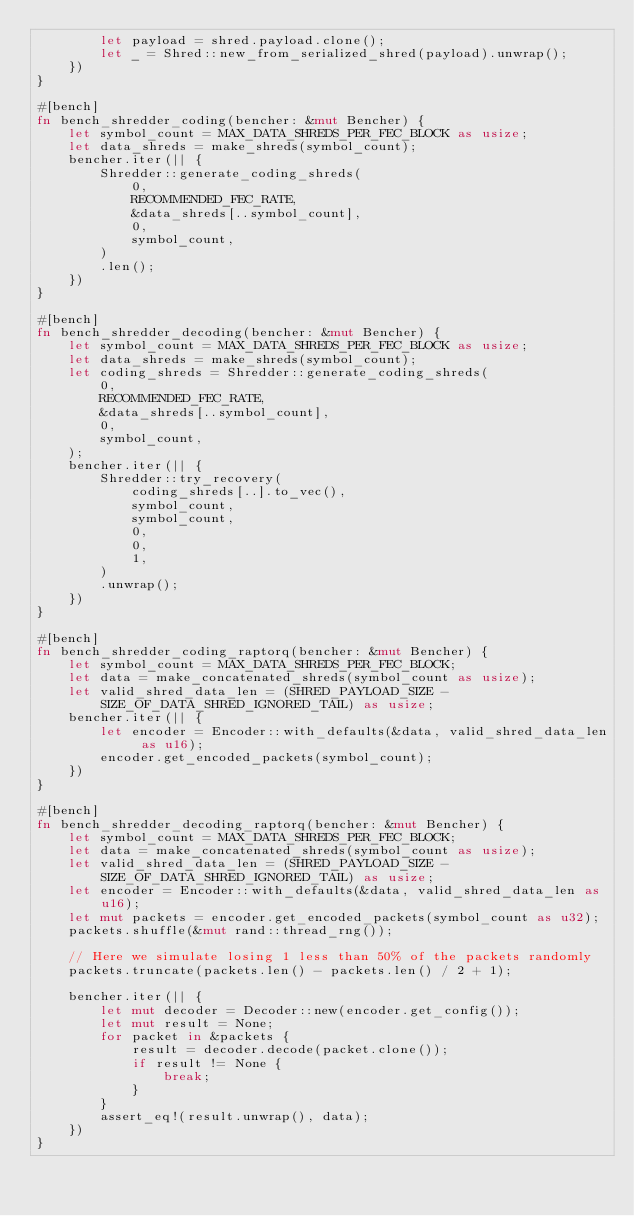Convert code to text. <code><loc_0><loc_0><loc_500><loc_500><_Rust_>        let payload = shred.payload.clone();
        let _ = Shred::new_from_serialized_shred(payload).unwrap();
    })
}

#[bench]
fn bench_shredder_coding(bencher: &mut Bencher) {
    let symbol_count = MAX_DATA_SHREDS_PER_FEC_BLOCK as usize;
    let data_shreds = make_shreds(symbol_count);
    bencher.iter(|| {
        Shredder::generate_coding_shreds(
            0,
            RECOMMENDED_FEC_RATE,
            &data_shreds[..symbol_count],
            0,
            symbol_count,
        )
        .len();
    })
}

#[bench]
fn bench_shredder_decoding(bencher: &mut Bencher) {
    let symbol_count = MAX_DATA_SHREDS_PER_FEC_BLOCK as usize;
    let data_shreds = make_shreds(symbol_count);
    let coding_shreds = Shredder::generate_coding_shreds(
        0,
        RECOMMENDED_FEC_RATE,
        &data_shreds[..symbol_count],
        0,
        symbol_count,
    );
    bencher.iter(|| {
        Shredder::try_recovery(
            coding_shreds[..].to_vec(),
            symbol_count,
            symbol_count,
            0,
            0,
            1,
        )
        .unwrap();
    })
}

#[bench]
fn bench_shredder_coding_raptorq(bencher: &mut Bencher) {
    let symbol_count = MAX_DATA_SHREDS_PER_FEC_BLOCK;
    let data = make_concatenated_shreds(symbol_count as usize);
    let valid_shred_data_len = (SHRED_PAYLOAD_SIZE - SIZE_OF_DATA_SHRED_IGNORED_TAIL) as usize;
    bencher.iter(|| {
        let encoder = Encoder::with_defaults(&data, valid_shred_data_len as u16);
        encoder.get_encoded_packets(symbol_count);
    })
}

#[bench]
fn bench_shredder_decoding_raptorq(bencher: &mut Bencher) {
    let symbol_count = MAX_DATA_SHREDS_PER_FEC_BLOCK;
    let data = make_concatenated_shreds(symbol_count as usize);
    let valid_shred_data_len = (SHRED_PAYLOAD_SIZE - SIZE_OF_DATA_SHRED_IGNORED_TAIL) as usize;
    let encoder = Encoder::with_defaults(&data, valid_shred_data_len as u16);
    let mut packets = encoder.get_encoded_packets(symbol_count as u32);
    packets.shuffle(&mut rand::thread_rng());

    // Here we simulate losing 1 less than 50% of the packets randomly
    packets.truncate(packets.len() - packets.len() / 2 + 1);

    bencher.iter(|| {
        let mut decoder = Decoder::new(encoder.get_config());
        let mut result = None;
        for packet in &packets {
            result = decoder.decode(packet.clone());
            if result != None {
                break;
            }
        }
        assert_eq!(result.unwrap(), data);
    })
}
</code> 